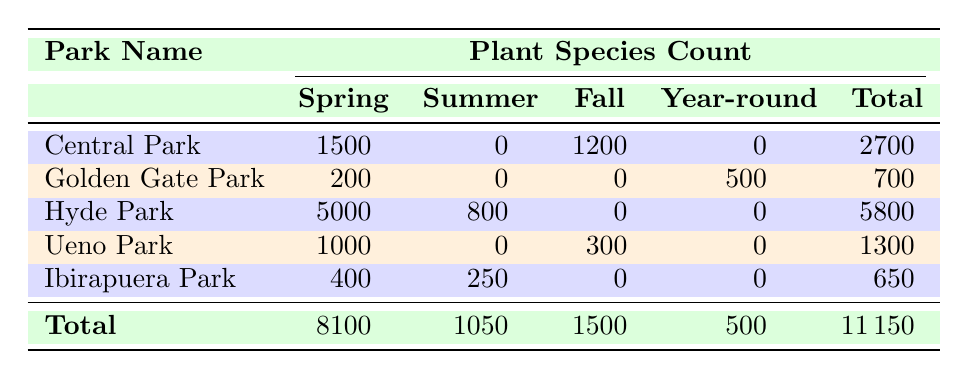What is the total count of plant species for Hyde Park? Looking at the row for Hyde Park, the total count of plant species is listed in the "Total" column, which shows a value of 5800.
Answer: 5800 Which park has the highest number of plant species during Spring? The table indicates that Hyde Park has 5000 plant species in Spring, which is the highest number compared to other parks.
Answer: Hyde Park Is there a park that has plant species count in Summer? By checking the Summer column, both Hyde Park and Ibirapuera Park have counts, so the answer is yes.
Answer: Yes What is the average count of plant species across all parks in Fall? The total count of plant species in Fall is 1500, and there are 5 parks. To find the average, we can divide 1500 by 5, which equals 300.
Answer: 300 Which park has the least diverse plant species count in the table? The Total row shows Ibirapuera Park has the least total count of plant species at 650, indicating it has the least diversity.
Answer: Ibirapuera Park What is the total plant species count during Spring across all parks? Summing the Spring counts from the table: 1500 (Central) + 200 (Golden Gate) + 5000 (Hyde) + 1000 (Ueno) + 400 (Ibirapuera) equals 8100.
Answer: 8100 Is there any park that has plant species available all year round? The table shows that only Golden Gate Park has a plant species count indicated in the Year-round column, so the answer is yes.
Answer: Yes What is the difference in total plant species count between Central Park and Golden Gate Park? Central Park has a total count of 2700 and Golden Gate Park has 700. The difference is calculated as 2700 - 700, which equals 2000.
Answer: 2000 During which season does Ibirapuera Park have more plant species, Spring or Summer? Ibirapuera Park has 400 plant species in Spring and 250 in Summer, indicating that Spring has a greater count.
Answer: Spring 